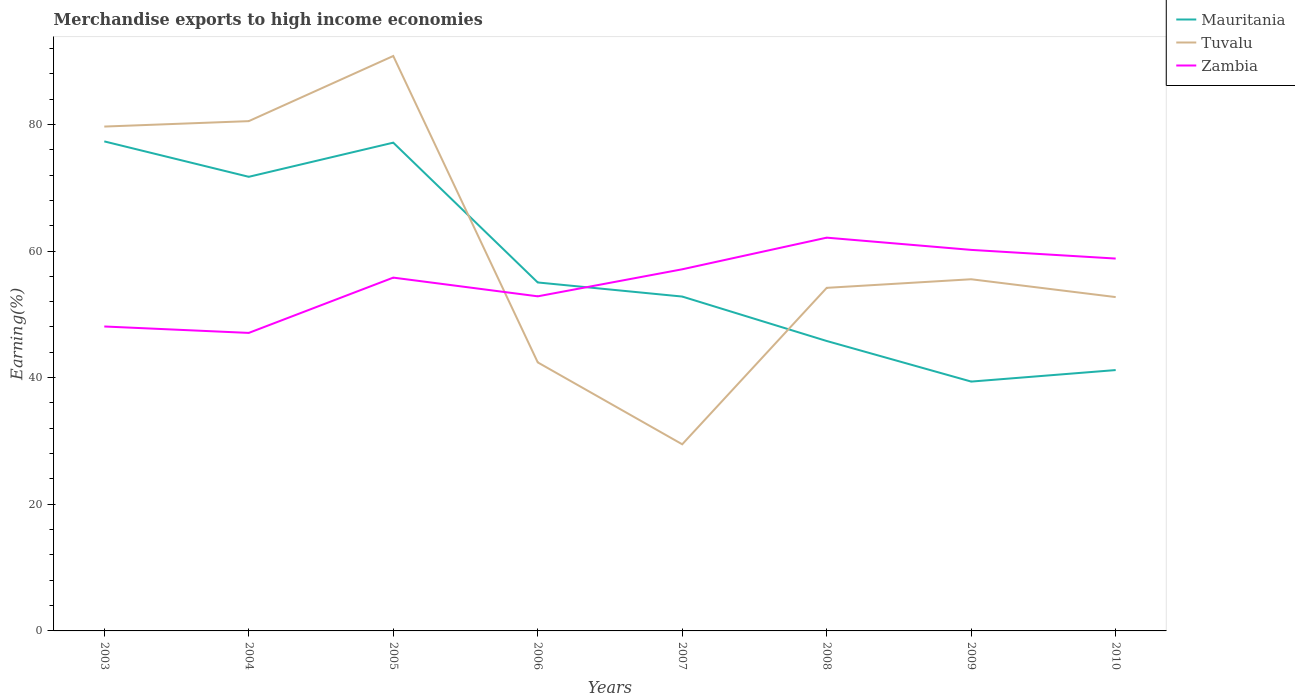How many different coloured lines are there?
Your answer should be compact. 3. Does the line corresponding to Mauritania intersect with the line corresponding to Zambia?
Offer a very short reply. Yes. Across all years, what is the maximum percentage of amount earned from merchandise exports in Tuvalu?
Offer a terse response. 29.47. In which year was the percentage of amount earned from merchandise exports in Mauritania maximum?
Keep it short and to the point. 2009. What is the total percentage of amount earned from merchandise exports in Mauritania in the graph?
Provide a short and direct response. 6.41. What is the difference between the highest and the second highest percentage of amount earned from merchandise exports in Mauritania?
Make the answer very short. 37.93. What is the difference between the highest and the lowest percentage of amount earned from merchandise exports in Mauritania?
Ensure brevity in your answer.  3. Is the percentage of amount earned from merchandise exports in Mauritania strictly greater than the percentage of amount earned from merchandise exports in Tuvalu over the years?
Your answer should be very brief. No. How many lines are there?
Provide a short and direct response. 3. How many years are there in the graph?
Your answer should be compact. 8. Are the values on the major ticks of Y-axis written in scientific E-notation?
Make the answer very short. No. Does the graph contain any zero values?
Ensure brevity in your answer.  No. Where does the legend appear in the graph?
Offer a very short reply. Top right. How many legend labels are there?
Provide a succinct answer. 3. What is the title of the graph?
Keep it short and to the point. Merchandise exports to high income economies. What is the label or title of the Y-axis?
Give a very brief answer. Earning(%). What is the Earning(%) of Mauritania in 2003?
Keep it short and to the point. 77.31. What is the Earning(%) in Tuvalu in 2003?
Make the answer very short. 79.65. What is the Earning(%) in Zambia in 2003?
Provide a short and direct response. 48.08. What is the Earning(%) in Mauritania in 2004?
Give a very brief answer. 71.72. What is the Earning(%) in Tuvalu in 2004?
Ensure brevity in your answer.  80.51. What is the Earning(%) of Zambia in 2004?
Your answer should be compact. 47.07. What is the Earning(%) in Mauritania in 2005?
Provide a succinct answer. 77.11. What is the Earning(%) in Tuvalu in 2005?
Your answer should be very brief. 90.8. What is the Earning(%) of Zambia in 2005?
Offer a very short reply. 55.8. What is the Earning(%) of Mauritania in 2006?
Your response must be concise. 55.03. What is the Earning(%) of Tuvalu in 2006?
Offer a very short reply. 42.41. What is the Earning(%) in Zambia in 2006?
Make the answer very short. 52.84. What is the Earning(%) in Mauritania in 2007?
Give a very brief answer. 52.81. What is the Earning(%) in Tuvalu in 2007?
Make the answer very short. 29.47. What is the Earning(%) in Zambia in 2007?
Provide a short and direct response. 57.11. What is the Earning(%) of Mauritania in 2008?
Ensure brevity in your answer.  45.79. What is the Earning(%) of Tuvalu in 2008?
Provide a succinct answer. 54.18. What is the Earning(%) of Zambia in 2008?
Provide a short and direct response. 62.11. What is the Earning(%) of Mauritania in 2009?
Make the answer very short. 39.38. What is the Earning(%) of Tuvalu in 2009?
Your response must be concise. 55.54. What is the Earning(%) in Zambia in 2009?
Provide a short and direct response. 60.18. What is the Earning(%) of Mauritania in 2010?
Provide a succinct answer. 41.2. What is the Earning(%) of Tuvalu in 2010?
Ensure brevity in your answer.  52.72. What is the Earning(%) in Zambia in 2010?
Offer a very short reply. 58.81. Across all years, what is the maximum Earning(%) in Mauritania?
Your answer should be compact. 77.31. Across all years, what is the maximum Earning(%) of Tuvalu?
Give a very brief answer. 90.8. Across all years, what is the maximum Earning(%) of Zambia?
Give a very brief answer. 62.11. Across all years, what is the minimum Earning(%) of Mauritania?
Ensure brevity in your answer.  39.38. Across all years, what is the minimum Earning(%) in Tuvalu?
Offer a very short reply. 29.47. Across all years, what is the minimum Earning(%) of Zambia?
Make the answer very short. 47.07. What is the total Earning(%) of Mauritania in the graph?
Make the answer very short. 460.35. What is the total Earning(%) of Tuvalu in the graph?
Ensure brevity in your answer.  485.29. What is the total Earning(%) of Zambia in the graph?
Provide a short and direct response. 441.99. What is the difference between the Earning(%) of Mauritania in 2003 and that in 2004?
Provide a short and direct response. 5.59. What is the difference between the Earning(%) in Tuvalu in 2003 and that in 2004?
Your response must be concise. -0.86. What is the difference between the Earning(%) of Zambia in 2003 and that in 2004?
Provide a short and direct response. 1.01. What is the difference between the Earning(%) of Mauritania in 2003 and that in 2005?
Make the answer very short. 0.2. What is the difference between the Earning(%) in Tuvalu in 2003 and that in 2005?
Your answer should be compact. -11.15. What is the difference between the Earning(%) of Zambia in 2003 and that in 2005?
Offer a very short reply. -7.72. What is the difference between the Earning(%) in Mauritania in 2003 and that in 2006?
Your response must be concise. 22.28. What is the difference between the Earning(%) of Tuvalu in 2003 and that in 2006?
Provide a succinct answer. 37.24. What is the difference between the Earning(%) in Zambia in 2003 and that in 2006?
Give a very brief answer. -4.76. What is the difference between the Earning(%) in Mauritania in 2003 and that in 2007?
Provide a short and direct response. 24.51. What is the difference between the Earning(%) of Tuvalu in 2003 and that in 2007?
Make the answer very short. 50.18. What is the difference between the Earning(%) in Zambia in 2003 and that in 2007?
Keep it short and to the point. -9.03. What is the difference between the Earning(%) in Mauritania in 2003 and that in 2008?
Your answer should be very brief. 31.52. What is the difference between the Earning(%) of Tuvalu in 2003 and that in 2008?
Your response must be concise. 25.47. What is the difference between the Earning(%) of Zambia in 2003 and that in 2008?
Provide a succinct answer. -14.03. What is the difference between the Earning(%) in Mauritania in 2003 and that in 2009?
Keep it short and to the point. 37.93. What is the difference between the Earning(%) in Tuvalu in 2003 and that in 2009?
Keep it short and to the point. 24.12. What is the difference between the Earning(%) in Zambia in 2003 and that in 2009?
Make the answer very short. -12.1. What is the difference between the Earning(%) of Mauritania in 2003 and that in 2010?
Provide a short and direct response. 36.11. What is the difference between the Earning(%) of Tuvalu in 2003 and that in 2010?
Offer a very short reply. 26.93. What is the difference between the Earning(%) of Zambia in 2003 and that in 2010?
Make the answer very short. -10.73. What is the difference between the Earning(%) in Mauritania in 2004 and that in 2005?
Offer a very short reply. -5.39. What is the difference between the Earning(%) in Tuvalu in 2004 and that in 2005?
Keep it short and to the point. -10.29. What is the difference between the Earning(%) in Zambia in 2004 and that in 2005?
Keep it short and to the point. -8.73. What is the difference between the Earning(%) in Mauritania in 2004 and that in 2006?
Keep it short and to the point. 16.69. What is the difference between the Earning(%) in Tuvalu in 2004 and that in 2006?
Provide a short and direct response. 38.1. What is the difference between the Earning(%) in Zambia in 2004 and that in 2006?
Keep it short and to the point. -5.78. What is the difference between the Earning(%) of Mauritania in 2004 and that in 2007?
Provide a succinct answer. 18.91. What is the difference between the Earning(%) of Tuvalu in 2004 and that in 2007?
Keep it short and to the point. 51.04. What is the difference between the Earning(%) of Zambia in 2004 and that in 2007?
Keep it short and to the point. -10.05. What is the difference between the Earning(%) of Mauritania in 2004 and that in 2008?
Keep it short and to the point. 25.93. What is the difference between the Earning(%) in Tuvalu in 2004 and that in 2008?
Your answer should be compact. 26.33. What is the difference between the Earning(%) in Zambia in 2004 and that in 2008?
Your answer should be compact. -15.04. What is the difference between the Earning(%) in Mauritania in 2004 and that in 2009?
Make the answer very short. 32.34. What is the difference between the Earning(%) in Tuvalu in 2004 and that in 2009?
Offer a very short reply. 24.97. What is the difference between the Earning(%) of Zambia in 2004 and that in 2009?
Your answer should be very brief. -13.11. What is the difference between the Earning(%) in Mauritania in 2004 and that in 2010?
Your answer should be compact. 30.52. What is the difference between the Earning(%) of Tuvalu in 2004 and that in 2010?
Ensure brevity in your answer.  27.79. What is the difference between the Earning(%) of Zambia in 2004 and that in 2010?
Offer a terse response. -11.74. What is the difference between the Earning(%) in Mauritania in 2005 and that in 2006?
Provide a succinct answer. 22.08. What is the difference between the Earning(%) in Tuvalu in 2005 and that in 2006?
Provide a succinct answer. 48.39. What is the difference between the Earning(%) of Zambia in 2005 and that in 2006?
Keep it short and to the point. 2.95. What is the difference between the Earning(%) of Mauritania in 2005 and that in 2007?
Give a very brief answer. 24.31. What is the difference between the Earning(%) in Tuvalu in 2005 and that in 2007?
Make the answer very short. 61.32. What is the difference between the Earning(%) of Zambia in 2005 and that in 2007?
Your answer should be compact. -1.32. What is the difference between the Earning(%) of Mauritania in 2005 and that in 2008?
Give a very brief answer. 31.32. What is the difference between the Earning(%) in Tuvalu in 2005 and that in 2008?
Give a very brief answer. 36.62. What is the difference between the Earning(%) in Zambia in 2005 and that in 2008?
Provide a succinct answer. -6.31. What is the difference between the Earning(%) of Mauritania in 2005 and that in 2009?
Keep it short and to the point. 37.73. What is the difference between the Earning(%) of Tuvalu in 2005 and that in 2009?
Offer a terse response. 35.26. What is the difference between the Earning(%) in Zambia in 2005 and that in 2009?
Ensure brevity in your answer.  -4.38. What is the difference between the Earning(%) of Mauritania in 2005 and that in 2010?
Provide a short and direct response. 35.91. What is the difference between the Earning(%) in Tuvalu in 2005 and that in 2010?
Your answer should be compact. 38.08. What is the difference between the Earning(%) in Zambia in 2005 and that in 2010?
Your response must be concise. -3.01. What is the difference between the Earning(%) in Mauritania in 2006 and that in 2007?
Provide a short and direct response. 2.23. What is the difference between the Earning(%) of Tuvalu in 2006 and that in 2007?
Offer a terse response. 12.94. What is the difference between the Earning(%) in Zambia in 2006 and that in 2007?
Provide a short and direct response. -4.27. What is the difference between the Earning(%) of Mauritania in 2006 and that in 2008?
Offer a terse response. 9.24. What is the difference between the Earning(%) of Tuvalu in 2006 and that in 2008?
Ensure brevity in your answer.  -11.77. What is the difference between the Earning(%) in Zambia in 2006 and that in 2008?
Provide a short and direct response. -9.27. What is the difference between the Earning(%) of Mauritania in 2006 and that in 2009?
Offer a very short reply. 15.65. What is the difference between the Earning(%) of Tuvalu in 2006 and that in 2009?
Offer a terse response. -13.13. What is the difference between the Earning(%) in Zambia in 2006 and that in 2009?
Your answer should be very brief. -7.33. What is the difference between the Earning(%) of Mauritania in 2006 and that in 2010?
Provide a succinct answer. 13.83. What is the difference between the Earning(%) in Tuvalu in 2006 and that in 2010?
Offer a terse response. -10.31. What is the difference between the Earning(%) in Zambia in 2006 and that in 2010?
Ensure brevity in your answer.  -5.96. What is the difference between the Earning(%) of Mauritania in 2007 and that in 2008?
Give a very brief answer. 7.02. What is the difference between the Earning(%) in Tuvalu in 2007 and that in 2008?
Your answer should be compact. -24.71. What is the difference between the Earning(%) in Zambia in 2007 and that in 2008?
Your answer should be compact. -5. What is the difference between the Earning(%) in Mauritania in 2007 and that in 2009?
Your answer should be compact. 13.43. What is the difference between the Earning(%) of Tuvalu in 2007 and that in 2009?
Make the answer very short. -26.06. What is the difference between the Earning(%) in Zambia in 2007 and that in 2009?
Your answer should be compact. -3.06. What is the difference between the Earning(%) in Mauritania in 2007 and that in 2010?
Make the answer very short. 11.61. What is the difference between the Earning(%) of Tuvalu in 2007 and that in 2010?
Provide a short and direct response. -23.25. What is the difference between the Earning(%) of Zambia in 2007 and that in 2010?
Offer a terse response. -1.69. What is the difference between the Earning(%) in Mauritania in 2008 and that in 2009?
Your answer should be compact. 6.41. What is the difference between the Earning(%) in Tuvalu in 2008 and that in 2009?
Keep it short and to the point. -1.36. What is the difference between the Earning(%) in Zambia in 2008 and that in 2009?
Your answer should be very brief. 1.93. What is the difference between the Earning(%) of Mauritania in 2008 and that in 2010?
Your answer should be very brief. 4.59. What is the difference between the Earning(%) in Tuvalu in 2008 and that in 2010?
Provide a short and direct response. 1.46. What is the difference between the Earning(%) of Zambia in 2008 and that in 2010?
Provide a short and direct response. 3.3. What is the difference between the Earning(%) of Mauritania in 2009 and that in 2010?
Your response must be concise. -1.82. What is the difference between the Earning(%) in Tuvalu in 2009 and that in 2010?
Your answer should be very brief. 2.82. What is the difference between the Earning(%) in Zambia in 2009 and that in 2010?
Keep it short and to the point. 1.37. What is the difference between the Earning(%) of Mauritania in 2003 and the Earning(%) of Tuvalu in 2004?
Your response must be concise. -3.2. What is the difference between the Earning(%) in Mauritania in 2003 and the Earning(%) in Zambia in 2004?
Your response must be concise. 30.25. What is the difference between the Earning(%) in Tuvalu in 2003 and the Earning(%) in Zambia in 2004?
Your response must be concise. 32.59. What is the difference between the Earning(%) of Mauritania in 2003 and the Earning(%) of Tuvalu in 2005?
Provide a succinct answer. -13.49. What is the difference between the Earning(%) in Mauritania in 2003 and the Earning(%) in Zambia in 2005?
Your answer should be very brief. 21.52. What is the difference between the Earning(%) in Tuvalu in 2003 and the Earning(%) in Zambia in 2005?
Provide a succinct answer. 23.86. What is the difference between the Earning(%) in Mauritania in 2003 and the Earning(%) in Tuvalu in 2006?
Your answer should be compact. 34.9. What is the difference between the Earning(%) of Mauritania in 2003 and the Earning(%) of Zambia in 2006?
Keep it short and to the point. 24.47. What is the difference between the Earning(%) in Tuvalu in 2003 and the Earning(%) in Zambia in 2006?
Your answer should be compact. 26.81. What is the difference between the Earning(%) of Mauritania in 2003 and the Earning(%) of Tuvalu in 2007?
Keep it short and to the point. 47.84. What is the difference between the Earning(%) in Mauritania in 2003 and the Earning(%) in Zambia in 2007?
Your answer should be compact. 20.2. What is the difference between the Earning(%) of Tuvalu in 2003 and the Earning(%) of Zambia in 2007?
Make the answer very short. 22.54. What is the difference between the Earning(%) in Mauritania in 2003 and the Earning(%) in Tuvalu in 2008?
Your response must be concise. 23.13. What is the difference between the Earning(%) of Mauritania in 2003 and the Earning(%) of Zambia in 2008?
Provide a short and direct response. 15.2. What is the difference between the Earning(%) in Tuvalu in 2003 and the Earning(%) in Zambia in 2008?
Provide a short and direct response. 17.55. What is the difference between the Earning(%) in Mauritania in 2003 and the Earning(%) in Tuvalu in 2009?
Offer a very short reply. 21.77. What is the difference between the Earning(%) in Mauritania in 2003 and the Earning(%) in Zambia in 2009?
Your answer should be compact. 17.14. What is the difference between the Earning(%) in Tuvalu in 2003 and the Earning(%) in Zambia in 2009?
Ensure brevity in your answer.  19.48. What is the difference between the Earning(%) in Mauritania in 2003 and the Earning(%) in Tuvalu in 2010?
Your answer should be compact. 24.59. What is the difference between the Earning(%) of Mauritania in 2003 and the Earning(%) of Zambia in 2010?
Offer a very short reply. 18.5. What is the difference between the Earning(%) of Tuvalu in 2003 and the Earning(%) of Zambia in 2010?
Keep it short and to the point. 20.85. What is the difference between the Earning(%) in Mauritania in 2004 and the Earning(%) in Tuvalu in 2005?
Provide a succinct answer. -19.08. What is the difference between the Earning(%) of Mauritania in 2004 and the Earning(%) of Zambia in 2005?
Your response must be concise. 15.92. What is the difference between the Earning(%) in Tuvalu in 2004 and the Earning(%) in Zambia in 2005?
Give a very brief answer. 24.71. What is the difference between the Earning(%) in Mauritania in 2004 and the Earning(%) in Tuvalu in 2006?
Offer a very short reply. 29.31. What is the difference between the Earning(%) of Mauritania in 2004 and the Earning(%) of Zambia in 2006?
Your answer should be compact. 18.88. What is the difference between the Earning(%) in Tuvalu in 2004 and the Earning(%) in Zambia in 2006?
Keep it short and to the point. 27.67. What is the difference between the Earning(%) in Mauritania in 2004 and the Earning(%) in Tuvalu in 2007?
Ensure brevity in your answer.  42.24. What is the difference between the Earning(%) of Mauritania in 2004 and the Earning(%) of Zambia in 2007?
Give a very brief answer. 14.61. What is the difference between the Earning(%) of Tuvalu in 2004 and the Earning(%) of Zambia in 2007?
Give a very brief answer. 23.4. What is the difference between the Earning(%) in Mauritania in 2004 and the Earning(%) in Tuvalu in 2008?
Your answer should be compact. 17.54. What is the difference between the Earning(%) of Mauritania in 2004 and the Earning(%) of Zambia in 2008?
Ensure brevity in your answer.  9.61. What is the difference between the Earning(%) of Tuvalu in 2004 and the Earning(%) of Zambia in 2008?
Ensure brevity in your answer.  18.4. What is the difference between the Earning(%) of Mauritania in 2004 and the Earning(%) of Tuvalu in 2009?
Make the answer very short. 16.18. What is the difference between the Earning(%) in Mauritania in 2004 and the Earning(%) in Zambia in 2009?
Your response must be concise. 11.54. What is the difference between the Earning(%) of Tuvalu in 2004 and the Earning(%) of Zambia in 2009?
Your answer should be very brief. 20.34. What is the difference between the Earning(%) in Mauritania in 2004 and the Earning(%) in Tuvalu in 2010?
Your answer should be compact. 19. What is the difference between the Earning(%) in Mauritania in 2004 and the Earning(%) in Zambia in 2010?
Keep it short and to the point. 12.91. What is the difference between the Earning(%) of Tuvalu in 2004 and the Earning(%) of Zambia in 2010?
Give a very brief answer. 21.7. What is the difference between the Earning(%) in Mauritania in 2005 and the Earning(%) in Tuvalu in 2006?
Your response must be concise. 34.7. What is the difference between the Earning(%) of Mauritania in 2005 and the Earning(%) of Zambia in 2006?
Keep it short and to the point. 24.27. What is the difference between the Earning(%) in Tuvalu in 2005 and the Earning(%) in Zambia in 2006?
Provide a succinct answer. 37.96. What is the difference between the Earning(%) in Mauritania in 2005 and the Earning(%) in Tuvalu in 2007?
Offer a terse response. 47.64. What is the difference between the Earning(%) of Mauritania in 2005 and the Earning(%) of Zambia in 2007?
Ensure brevity in your answer.  20. What is the difference between the Earning(%) of Tuvalu in 2005 and the Earning(%) of Zambia in 2007?
Your response must be concise. 33.69. What is the difference between the Earning(%) of Mauritania in 2005 and the Earning(%) of Tuvalu in 2008?
Your answer should be very brief. 22.93. What is the difference between the Earning(%) of Mauritania in 2005 and the Earning(%) of Zambia in 2008?
Offer a terse response. 15. What is the difference between the Earning(%) of Tuvalu in 2005 and the Earning(%) of Zambia in 2008?
Keep it short and to the point. 28.69. What is the difference between the Earning(%) of Mauritania in 2005 and the Earning(%) of Tuvalu in 2009?
Your answer should be very brief. 21.57. What is the difference between the Earning(%) in Mauritania in 2005 and the Earning(%) in Zambia in 2009?
Make the answer very short. 16.94. What is the difference between the Earning(%) in Tuvalu in 2005 and the Earning(%) in Zambia in 2009?
Offer a very short reply. 30.62. What is the difference between the Earning(%) of Mauritania in 2005 and the Earning(%) of Tuvalu in 2010?
Ensure brevity in your answer.  24.39. What is the difference between the Earning(%) of Mauritania in 2005 and the Earning(%) of Zambia in 2010?
Give a very brief answer. 18.31. What is the difference between the Earning(%) in Tuvalu in 2005 and the Earning(%) in Zambia in 2010?
Provide a short and direct response. 31.99. What is the difference between the Earning(%) in Mauritania in 2006 and the Earning(%) in Tuvalu in 2007?
Keep it short and to the point. 25.56. What is the difference between the Earning(%) in Mauritania in 2006 and the Earning(%) in Zambia in 2007?
Your answer should be compact. -2.08. What is the difference between the Earning(%) of Tuvalu in 2006 and the Earning(%) of Zambia in 2007?
Your response must be concise. -14.7. What is the difference between the Earning(%) in Mauritania in 2006 and the Earning(%) in Tuvalu in 2008?
Provide a succinct answer. 0.85. What is the difference between the Earning(%) of Mauritania in 2006 and the Earning(%) of Zambia in 2008?
Offer a very short reply. -7.08. What is the difference between the Earning(%) of Tuvalu in 2006 and the Earning(%) of Zambia in 2008?
Your response must be concise. -19.7. What is the difference between the Earning(%) in Mauritania in 2006 and the Earning(%) in Tuvalu in 2009?
Ensure brevity in your answer.  -0.51. What is the difference between the Earning(%) in Mauritania in 2006 and the Earning(%) in Zambia in 2009?
Provide a short and direct response. -5.14. What is the difference between the Earning(%) in Tuvalu in 2006 and the Earning(%) in Zambia in 2009?
Offer a terse response. -17.77. What is the difference between the Earning(%) in Mauritania in 2006 and the Earning(%) in Tuvalu in 2010?
Make the answer very short. 2.31. What is the difference between the Earning(%) in Mauritania in 2006 and the Earning(%) in Zambia in 2010?
Your answer should be very brief. -3.78. What is the difference between the Earning(%) of Tuvalu in 2006 and the Earning(%) of Zambia in 2010?
Offer a very short reply. -16.4. What is the difference between the Earning(%) of Mauritania in 2007 and the Earning(%) of Tuvalu in 2008?
Give a very brief answer. -1.38. What is the difference between the Earning(%) in Mauritania in 2007 and the Earning(%) in Zambia in 2008?
Offer a very short reply. -9.3. What is the difference between the Earning(%) in Tuvalu in 2007 and the Earning(%) in Zambia in 2008?
Give a very brief answer. -32.63. What is the difference between the Earning(%) of Mauritania in 2007 and the Earning(%) of Tuvalu in 2009?
Give a very brief answer. -2.73. What is the difference between the Earning(%) of Mauritania in 2007 and the Earning(%) of Zambia in 2009?
Your response must be concise. -7.37. What is the difference between the Earning(%) of Tuvalu in 2007 and the Earning(%) of Zambia in 2009?
Give a very brief answer. -30.7. What is the difference between the Earning(%) of Mauritania in 2007 and the Earning(%) of Tuvalu in 2010?
Offer a very short reply. 0.08. What is the difference between the Earning(%) of Mauritania in 2007 and the Earning(%) of Zambia in 2010?
Provide a succinct answer. -6. What is the difference between the Earning(%) of Tuvalu in 2007 and the Earning(%) of Zambia in 2010?
Your answer should be very brief. -29.33. What is the difference between the Earning(%) in Mauritania in 2008 and the Earning(%) in Tuvalu in 2009?
Give a very brief answer. -9.75. What is the difference between the Earning(%) of Mauritania in 2008 and the Earning(%) of Zambia in 2009?
Provide a succinct answer. -14.39. What is the difference between the Earning(%) in Tuvalu in 2008 and the Earning(%) in Zambia in 2009?
Offer a very short reply. -5.99. What is the difference between the Earning(%) in Mauritania in 2008 and the Earning(%) in Tuvalu in 2010?
Make the answer very short. -6.93. What is the difference between the Earning(%) of Mauritania in 2008 and the Earning(%) of Zambia in 2010?
Your response must be concise. -13.02. What is the difference between the Earning(%) of Tuvalu in 2008 and the Earning(%) of Zambia in 2010?
Make the answer very short. -4.63. What is the difference between the Earning(%) of Mauritania in 2009 and the Earning(%) of Tuvalu in 2010?
Your response must be concise. -13.34. What is the difference between the Earning(%) of Mauritania in 2009 and the Earning(%) of Zambia in 2010?
Offer a very short reply. -19.43. What is the difference between the Earning(%) in Tuvalu in 2009 and the Earning(%) in Zambia in 2010?
Keep it short and to the point. -3.27. What is the average Earning(%) in Mauritania per year?
Offer a very short reply. 57.54. What is the average Earning(%) of Tuvalu per year?
Your answer should be very brief. 60.66. What is the average Earning(%) in Zambia per year?
Offer a terse response. 55.25. In the year 2003, what is the difference between the Earning(%) in Mauritania and Earning(%) in Tuvalu?
Your response must be concise. -2.34. In the year 2003, what is the difference between the Earning(%) in Mauritania and Earning(%) in Zambia?
Offer a terse response. 29.23. In the year 2003, what is the difference between the Earning(%) of Tuvalu and Earning(%) of Zambia?
Offer a very short reply. 31.57. In the year 2004, what is the difference between the Earning(%) in Mauritania and Earning(%) in Tuvalu?
Your response must be concise. -8.79. In the year 2004, what is the difference between the Earning(%) in Mauritania and Earning(%) in Zambia?
Your answer should be very brief. 24.65. In the year 2004, what is the difference between the Earning(%) of Tuvalu and Earning(%) of Zambia?
Keep it short and to the point. 33.45. In the year 2005, what is the difference between the Earning(%) in Mauritania and Earning(%) in Tuvalu?
Provide a short and direct response. -13.69. In the year 2005, what is the difference between the Earning(%) of Mauritania and Earning(%) of Zambia?
Provide a short and direct response. 21.32. In the year 2005, what is the difference between the Earning(%) in Tuvalu and Earning(%) in Zambia?
Offer a terse response. 35. In the year 2006, what is the difference between the Earning(%) of Mauritania and Earning(%) of Tuvalu?
Ensure brevity in your answer.  12.62. In the year 2006, what is the difference between the Earning(%) of Mauritania and Earning(%) of Zambia?
Your answer should be compact. 2.19. In the year 2006, what is the difference between the Earning(%) of Tuvalu and Earning(%) of Zambia?
Provide a short and direct response. -10.43. In the year 2007, what is the difference between the Earning(%) in Mauritania and Earning(%) in Tuvalu?
Your response must be concise. 23.33. In the year 2007, what is the difference between the Earning(%) of Mauritania and Earning(%) of Zambia?
Provide a succinct answer. -4.31. In the year 2007, what is the difference between the Earning(%) in Tuvalu and Earning(%) in Zambia?
Your answer should be very brief. -27.64. In the year 2008, what is the difference between the Earning(%) in Mauritania and Earning(%) in Tuvalu?
Offer a very short reply. -8.39. In the year 2008, what is the difference between the Earning(%) of Mauritania and Earning(%) of Zambia?
Your response must be concise. -16.32. In the year 2008, what is the difference between the Earning(%) of Tuvalu and Earning(%) of Zambia?
Your answer should be very brief. -7.93. In the year 2009, what is the difference between the Earning(%) of Mauritania and Earning(%) of Tuvalu?
Your response must be concise. -16.16. In the year 2009, what is the difference between the Earning(%) in Mauritania and Earning(%) in Zambia?
Ensure brevity in your answer.  -20.8. In the year 2009, what is the difference between the Earning(%) of Tuvalu and Earning(%) of Zambia?
Provide a succinct answer. -4.64. In the year 2010, what is the difference between the Earning(%) in Mauritania and Earning(%) in Tuvalu?
Provide a short and direct response. -11.52. In the year 2010, what is the difference between the Earning(%) in Mauritania and Earning(%) in Zambia?
Keep it short and to the point. -17.61. In the year 2010, what is the difference between the Earning(%) in Tuvalu and Earning(%) in Zambia?
Give a very brief answer. -6.08. What is the ratio of the Earning(%) in Mauritania in 2003 to that in 2004?
Provide a short and direct response. 1.08. What is the ratio of the Earning(%) of Tuvalu in 2003 to that in 2004?
Give a very brief answer. 0.99. What is the ratio of the Earning(%) of Zambia in 2003 to that in 2004?
Your answer should be compact. 1.02. What is the ratio of the Earning(%) in Tuvalu in 2003 to that in 2005?
Keep it short and to the point. 0.88. What is the ratio of the Earning(%) of Zambia in 2003 to that in 2005?
Offer a very short reply. 0.86. What is the ratio of the Earning(%) in Mauritania in 2003 to that in 2006?
Offer a very short reply. 1.4. What is the ratio of the Earning(%) of Tuvalu in 2003 to that in 2006?
Keep it short and to the point. 1.88. What is the ratio of the Earning(%) in Zambia in 2003 to that in 2006?
Make the answer very short. 0.91. What is the ratio of the Earning(%) of Mauritania in 2003 to that in 2007?
Your answer should be compact. 1.46. What is the ratio of the Earning(%) of Tuvalu in 2003 to that in 2007?
Your answer should be compact. 2.7. What is the ratio of the Earning(%) of Zambia in 2003 to that in 2007?
Provide a short and direct response. 0.84. What is the ratio of the Earning(%) in Mauritania in 2003 to that in 2008?
Offer a very short reply. 1.69. What is the ratio of the Earning(%) of Tuvalu in 2003 to that in 2008?
Your answer should be compact. 1.47. What is the ratio of the Earning(%) of Zambia in 2003 to that in 2008?
Give a very brief answer. 0.77. What is the ratio of the Earning(%) of Mauritania in 2003 to that in 2009?
Make the answer very short. 1.96. What is the ratio of the Earning(%) in Tuvalu in 2003 to that in 2009?
Your answer should be compact. 1.43. What is the ratio of the Earning(%) in Zambia in 2003 to that in 2009?
Give a very brief answer. 0.8. What is the ratio of the Earning(%) in Mauritania in 2003 to that in 2010?
Your answer should be very brief. 1.88. What is the ratio of the Earning(%) in Tuvalu in 2003 to that in 2010?
Offer a very short reply. 1.51. What is the ratio of the Earning(%) in Zambia in 2003 to that in 2010?
Your response must be concise. 0.82. What is the ratio of the Earning(%) in Mauritania in 2004 to that in 2005?
Your answer should be compact. 0.93. What is the ratio of the Earning(%) of Tuvalu in 2004 to that in 2005?
Your answer should be very brief. 0.89. What is the ratio of the Earning(%) in Zambia in 2004 to that in 2005?
Ensure brevity in your answer.  0.84. What is the ratio of the Earning(%) in Mauritania in 2004 to that in 2006?
Your answer should be very brief. 1.3. What is the ratio of the Earning(%) of Tuvalu in 2004 to that in 2006?
Your answer should be very brief. 1.9. What is the ratio of the Earning(%) in Zambia in 2004 to that in 2006?
Your answer should be very brief. 0.89. What is the ratio of the Earning(%) in Mauritania in 2004 to that in 2007?
Your answer should be compact. 1.36. What is the ratio of the Earning(%) in Tuvalu in 2004 to that in 2007?
Offer a very short reply. 2.73. What is the ratio of the Earning(%) in Zambia in 2004 to that in 2007?
Your response must be concise. 0.82. What is the ratio of the Earning(%) in Mauritania in 2004 to that in 2008?
Offer a terse response. 1.57. What is the ratio of the Earning(%) in Tuvalu in 2004 to that in 2008?
Offer a very short reply. 1.49. What is the ratio of the Earning(%) of Zambia in 2004 to that in 2008?
Ensure brevity in your answer.  0.76. What is the ratio of the Earning(%) of Mauritania in 2004 to that in 2009?
Make the answer very short. 1.82. What is the ratio of the Earning(%) in Tuvalu in 2004 to that in 2009?
Give a very brief answer. 1.45. What is the ratio of the Earning(%) of Zambia in 2004 to that in 2009?
Keep it short and to the point. 0.78. What is the ratio of the Earning(%) of Mauritania in 2004 to that in 2010?
Your answer should be very brief. 1.74. What is the ratio of the Earning(%) in Tuvalu in 2004 to that in 2010?
Ensure brevity in your answer.  1.53. What is the ratio of the Earning(%) of Zambia in 2004 to that in 2010?
Your answer should be very brief. 0.8. What is the ratio of the Earning(%) of Mauritania in 2005 to that in 2006?
Your answer should be compact. 1.4. What is the ratio of the Earning(%) of Tuvalu in 2005 to that in 2006?
Offer a terse response. 2.14. What is the ratio of the Earning(%) in Zambia in 2005 to that in 2006?
Keep it short and to the point. 1.06. What is the ratio of the Earning(%) of Mauritania in 2005 to that in 2007?
Your response must be concise. 1.46. What is the ratio of the Earning(%) of Tuvalu in 2005 to that in 2007?
Ensure brevity in your answer.  3.08. What is the ratio of the Earning(%) of Zambia in 2005 to that in 2007?
Keep it short and to the point. 0.98. What is the ratio of the Earning(%) in Mauritania in 2005 to that in 2008?
Provide a succinct answer. 1.68. What is the ratio of the Earning(%) of Tuvalu in 2005 to that in 2008?
Your response must be concise. 1.68. What is the ratio of the Earning(%) of Zambia in 2005 to that in 2008?
Make the answer very short. 0.9. What is the ratio of the Earning(%) in Mauritania in 2005 to that in 2009?
Your answer should be very brief. 1.96. What is the ratio of the Earning(%) in Tuvalu in 2005 to that in 2009?
Offer a very short reply. 1.63. What is the ratio of the Earning(%) in Zambia in 2005 to that in 2009?
Provide a short and direct response. 0.93. What is the ratio of the Earning(%) in Mauritania in 2005 to that in 2010?
Make the answer very short. 1.87. What is the ratio of the Earning(%) of Tuvalu in 2005 to that in 2010?
Make the answer very short. 1.72. What is the ratio of the Earning(%) of Zambia in 2005 to that in 2010?
Provide a short and direct response. 0.95. What is the ratio of the Earning(%) of Mauritania in 2006 to that in 2007?
Ensure brevity in your answer.  1.04. What is the ratio of the Earning(%) of Tuvalu in 2006 to that in 2007?
Ensure brevity in your answer.  1.44. What is the ratio of the Earning(%) of Zambia in 2006 to that in 2007?
Give a very brief answer. 0.93. What is the ratio of the Earning(%) of Mauritania in 2006 to that in 2008?
Your answer should be compact. 1.2. What is the ratio of the Earning(%) in Tuvalu in 2006 to that in 2008?
Your answer should be very brief. 0.78. What is the ratio of the Earning(%) of Zambia in 2006 to that in 2008?
Your response must be concise. 0.85. What is the ratio of the Earning(%) in Mauritania in 2006 to that in 2009?
Your answer should be compact. 1.4. What is the ratio of the Earning(%) of Tuvalu in 2006 to that in 2009?
Offer a terse response. 0.76. What is the ratio of the Earning(%) in Zambia in 2006 to that in 2009?
Make the answer very short. 0.88. What is the ratio of the Earning(%) of Mauritania in 2006 to that in 2010?
Provide a succinct answer. 1.34. What is the ratio of the Earning(%) in Tuvalu in 2006 to that in 2010?
Provide a short and direct response. 0.8. What is the ratio of the Earning(%) of Zambia in 2006 to that in 2010?
Make the answer very short. 0.9. What is the ratio of the Earning(%) in Mauritania in 2007 to that in 2008?
Provide a succinct answer. 1.15. What is the ratio of the Earning(%) of Tuvalu in 2007 to that in 2008?
Make the answer very short. 0.54. What is the ratio of the Earning(%) of Zambia in 2007 to that in 2008?
Offer a very short reply. 0.92. What is the ratio of the Earning(%) of Mauritania in 2007 to that in 2009?
Provide a succinct answer. 1.34. What is the ratio of the Earning(%) of Tuvalu in 2007 to that in 2009?
Provide a succinct answer. 0.53. What is the ratio of the Earning(%) in Zambia in 2007 to that in 2009?
Keep it short and to the point. 0.95. What is the ratio of the Earning(%) in Mauritania in 2007 to that in 2010?
Offer a terse response. 1.28. What is the ratio of the Earning(%) of Tuvalu in 2007 to that in 2010?
Keep it short and to the point. 0.56. What is the ratio of the Earning(%) of Zambia in 2007 to that in 2010?
Keep it short and to the point. 0.97. What is the ratio of the Earning(%) in Mauritania in 2008 to that in 2009?
Your answer should be compact. 1.16. What is the ratio of the Earning(%) of Tuvalu in 2008 to that in 2009?
Make the answer very short. 0.98. What is the ratio of the Earning(%) of Zambia in 2008 to that in 2009?
Offer a terse response. 1.03. What is the ratio of the Earning(%) in Mauritania in 2008 to that in 2010?
Provide a succinct answer. 1.11. What is the ratio of the Earning(%) of Tuvalu in 2008 to that in 2010?
Ensure brevity in your answer.  1.03. What is the ratio of the Earning(%) in Zambia in 2008 to that in 2010?
Offer a terse response. 1.06. What is the ratio of the Earning(%) of Mauritania in 2009 to that in 2010?
Offer a terse response. 0.96. What is the ratio of the Earning(%) in Tuvalu in 2009 to that in 2010?
Your response must be concise. 1.05. What is the ratio of the Earning(%) of Zambia in 2009 to that in 2010?
Keep it short and to the point. 1.02. What is the difference between the highest and the second highest Earning(%) in Mauritania?
Make the answer very short. 0.2. What is the difference between the highest and the second highest Earning(%) in Tuvalu?
Provide a short and direct response. 10.29. What is the difference between the highest and the second highest Earning(%) of Zambia?
Offer a terse response. 1.93. What is the difference between the highest and the lowest Earning(%) in Mauritania?
Provide a short and direct response. 37.93. What is the difference between the highest and the lowest Earning(%) in Tuvalu?
Give a very brief answer. 61.32. What is the difference between the highest and the lowest Earning(%) of Zambia?
Offer a terse response. 15.04. 